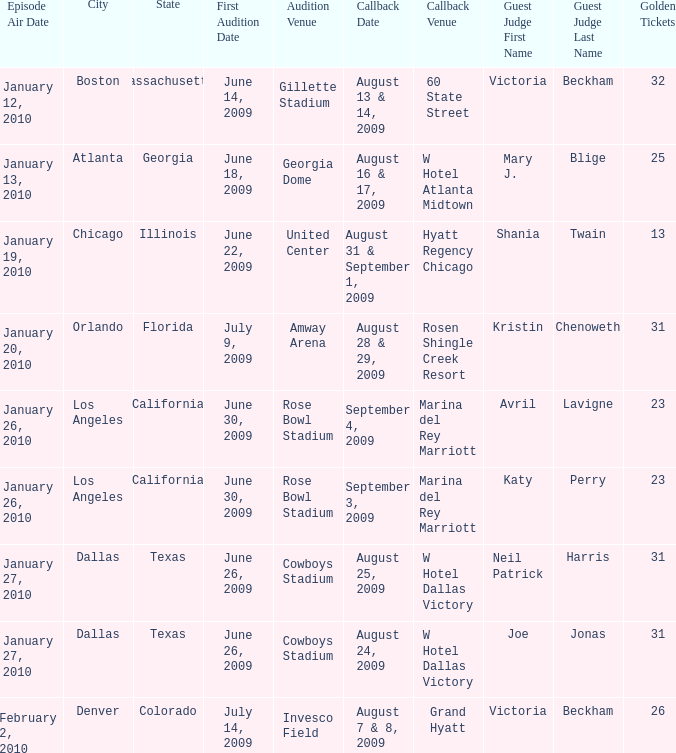Name the total number of golden tickets being rosen shingle creek resort 1.0. Could you help me parse every detail presented in this table? {'header': ['Episode Air Date', 'City', 'State', 'First Audition Date', 'Audition Venue', 'Callback Date', 'Callback Venue', 'Guest Judge First Name', 'Guest Judge Last Name', 'Golden Tickets'], 'rows': [['January 12, 2010', 'Boston', 'Massachusetts', 'June 14, 2009', 'Gillette Stadium', 'August 13 & 14, 2009', '60 State Street', 'Victoria', 'Beckham', '32'], ['January 13, 2010', 'Atlanta', 'Georgia', 'June 18, 2009', 'Georgia Dome', 'August 16 & 17, 2009', 'W Hotel Atlanta Midtown', 'Mary J.', 'Blige', '25'], ['January 19, 2010', 'Chicago', 'Illinois', 'June 22, 2009', 'United Center', 'August 31 & September 1, 2009', 'Hyatt Regency Chicago', 'Shania', 'Twain', '13'], ['January 20, 2010', 'Orlando', 'Florida', 'July 9, 2009', 'Amway Arena', 'August 28 & 29, 2009', 'Rosen Shingle Creek Resort', 'Kristin', 'Chenoweth', '31'], ['January 26, 2010', 'Los Angeles', 'California', 'June 30, 2009', 'Rose Bowl Stadium', 'September 4, 2009', 'Marina del Rey Marriott', 'Avril', 'Lavigne', '23'], ['January 26, 2010', 'Los Angeles', 'California', 'June 30, 2009', 'Rose Bowl Stadium', 'September 3, 2009', 'Marina del Rey Marriott', 'Katy', 'Perry', '23'], ['January 27, 2010', 'Dallas', 'Texas', 'June 26, 2009', 'Cowboys Stadium', 'August 25, 2009', 'W Hotel Dallas Victory', 'Neil Patrick', 'Harris', '31'], ['January 27, 2010', 'Dallas', 'Texas', 'June 26, 2009', 'Cowboys Stadium', 'August 24, 2009', 'W Hotel Dallas Victory', 'Joe', 'Jonas', '31'], ['February 2, 2010', 'Denver', 'Colorado', 'July 14, 2009', 'Invesco Field', 'August 7 & 8, 2009', 'Grand Hyatt', 'Victoria', 'Beckham', '26']]} 